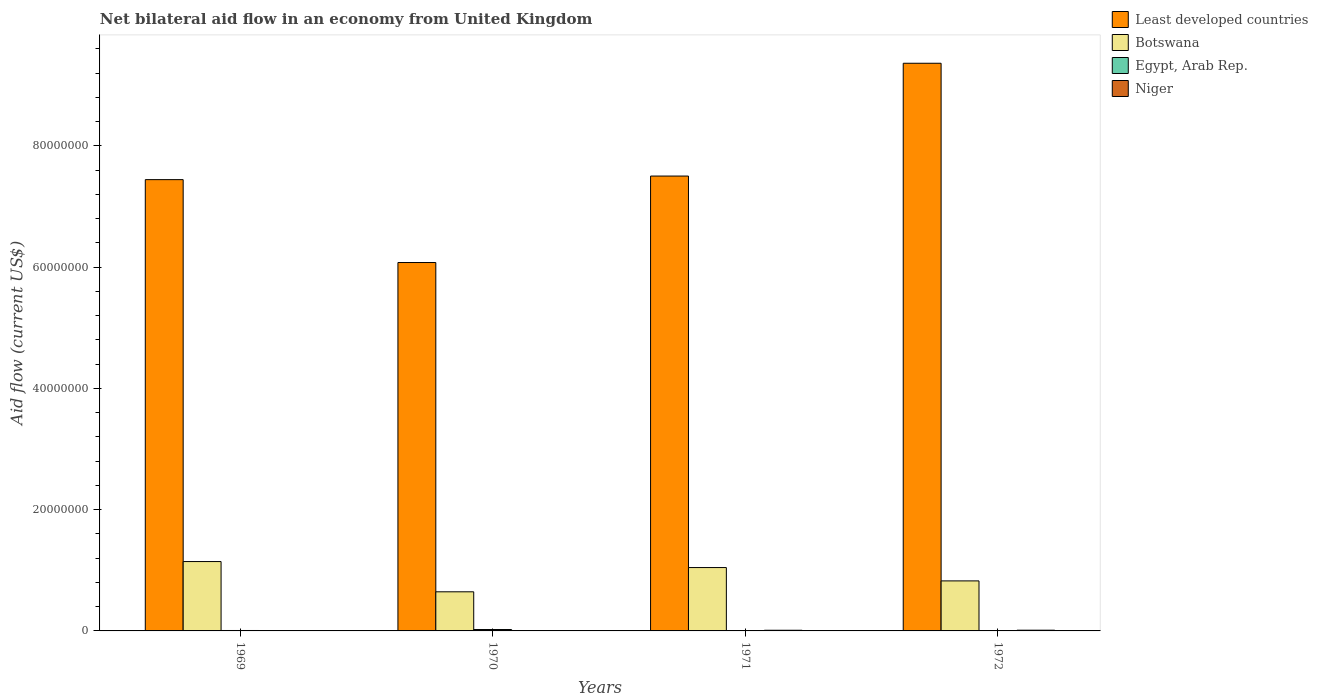How many groups of bars are there?
Provide a succinct answer. 4. Are the number of bars on each tick of the X-axis equal?
Make the answer very short. No. How many bars are there on the 2nd tick from the left?
Give a very brief answer. 4. In how many cases, is the number of bars for a given year not equal to the number of legend labels?
Give a very brief answer. 2. What is the net bilateral aid flow in Niger in 1969?
Make the answer very short. 3.00e+04. Across all years, what is the maximum net bilateral aid flow in Botswana?
Make the answer very short. 1.14e+07. Across all years, what is the minimum net bilateral aid flow in Botswana?
Make the answer very short. 6.45e+06. In which year was the net bilateral aid flow in Niger maximum?
Your answer should be very brief. 1972. What is the difference between the net bilateral aid flow in Egypt, Arab Rep. in 1972 and the net bilateral aid flow in Botswana in 1971?
Offer a very short reply. -1.04e+07. What is the average net bilateral aid flow in Botswana per year?
Your answer should be compact. 9.15e+06. In the year 1971, what is the difference between the net bilateral aid flow in Niger and net bilateral aid flow in Botswana?
Your response must be concise. -1.03e+07. In how many years, is the net bilateral aid flow in Egypt, Arab Rep. greater than 52000000 US$?
Provide a succinct answer. 0. Is the net bilateral aid flow in Niger in 1970 less than that in 1971?
Keep it short and to the point. Yes. Is the difference between the net bilateral aid flow in Niger in 1970 and 1971 greater than the difference between the net bilateral aid flow in Botswana in 1970 and 1971?
Provide a short and direct response. Yes. What is the difference between the highest and the second highest net bilateral aid flow in Least developed countries?
Keep it short and to the point. 1.86e+07. What is the difference between the highest and the lowest net bilateral aid flow in Egypt, Arab Rep.?
Make the answer very short. 2.30e+05. Is it the case that in every year, the sum of the net bilateral aid flow in Egypt, Arab Rep. and net bilateral aid flow in Least developed countries is greater than the sum of net bilateral aid flow in Botswana and net bilateral aid flow in Niger?
Your answer should be very brief. Yes. How many bars are there?
Give a very brief answer. 14. Are all the bars in the graph horizontal?
Provide a succinct answer. No. How many years are there in the graph?
Ensure brevity in your answer.  4. What is the difference between two consecutive major ticks on the Y-axis?
Offer a very short reply. 2.00e+07. Are the values on the major ticks of Y-axis written in scientific E-notation?
Your answer should be compact. No. Does the graph contain grids?
Provide a succinct answer. No. Where does the legend appear in the graph?
Provide a short and direct response. Top right. How are the legend labels stacked?
Make the answer very short. Vertical. What is the title of the graph?
Your answer should be compact. Net bilateral aid flow in an economy from United Kingdom. Does "Russian Federation" appear as one of the legend labels in the graph?
Make the answer very short. No. What is the label or title of the X-axis?
Offer a terse response. Years. What is the Aid flow (current US$) in Least developed countries in 1969?
Your response must be concise. 7.44e+07. What is the Aid flow (current US$) in Botswana in 1969?
Your answer should be compact. 1.14e+07. What is the Aid flow (current US$) in Least developed countries in 1970?
Your answer should be very brief. 6.08e+07. What is the Aid flow (current US$) of Botswana in 1970?
Offer a very short reply. 6.45e+06. What is the Aid flow (current US$) of Egypt, Arab Rep. in 1970?
Ensure brevity in your answer.  2.30e+05. What is the Aid flow (current US$) in Niger in 1970?
Keep it short and to the point. 3.00e+04. What is the Aid flow (current US$) in Least developed countries in 1971?
Make the answer very short. 7.50e+07. What is the Aid flow (current US$) of Botswana in 1971?
Provide a succinct answer. 1.04e+07. What is the Aid flow (current US$) of Least developed countries in 1972?
Offer a terse response. 9.36e+07. What is the Aid flow (current US$) of Botswana in 1972?
Your answer should be very brief. 8.25e+06. What is the Aid flow (current US$) in Egypt, Arab Rep. in 1972?
Keep it short and to the point. 0. Across all years, what is the maximum Aid flow (current US$) of Least developed countries?
Your answer should be compact. 9.36e+07. Across all years, what is the maximum Aid flow (current US$) in Botswana?
Make the answer very short. 1.14e+07. Across all years, what is the maximum Aid flow (current US$) in Egypt, Arab Rep.?
Provide a short and direct response. 2.30e+05. Across all years, what is the minimum Aid flow (current US$) of Least developed countries?
Your answer should be very brief. 6.08e+07. Across all years, what is the minimum Aid flow (current US$) in Botswana?
Provide a short and direct response. 6.45e+06. Across all years, what is the minimum Aid flow (current US$) in Egypt, Arab Rep.?
Provide a short and direct response. 0. Across all years, what is the minimum Aid flow (current US$) in Niger?
Provide a succinct answer. 3.00e+04. What is the total Aid flow (current US$) in Least developed countries in the graph?
Your response must be concise. 3.04e+08. What is the total Aid flow (current US$) in Botswana in the graph?
Give a very brief answer. 3.66e+07. What is the difference between the Aid flow (current US$) in Least developed countries in 1969 and that in 1970?
Your answer should be compact. 1.37e+07. What is the difference between the Aid flow (current US$) of Botswana in 1969 and that in 1970?
Ensure brevity in your answer.  4.99e+06. What is the difference between the Aid flow (current US$) of Niger in 1969 and that in 1970?
Your answer should be very brief. 0. What is the difference between the Aid flow (current US$) of Least developed countries in 1969 and that in 1971?
Offer a terse response. -5.90e+05. What is the difference between the Aid flow (current US$) in Botswana in 1969 and that in 1971?
Ensure brevity in your answer.  9.90e+05. What is the difference between the Aid flow (current US$) in Niger in 1969 and that in 1971?
Offer a very short reply. -8.00e+04. What is the difference between the Aid flow (current US$) of Least developed countries in 1969 and that in 1972?
Offer a terse response. -1.92e+07. What is the difference between the Aid flow (current US$) of Botswana in 1969 and that in 1972?
Provide a short and direct response. 3.19e+06. What is the difference between the Aid flow (current US$) of Least developed countries in 1970 and that in 1971?
Your answer should be compact. -1.43e+07. What is the difference between the Aid flow (current US$) of Least developed countries in 1970 and that in 1972?
Your answer should be compact. -3.29e+07. What is the difference between the Aid flow (current US$) of Botswana in 1970 and that in 1972?
Offer a terse response. -1.80e+06. What is the difference between the Aid flow (current US$) in Niger in 1970 and that in 1972?
Offer a very short reply. -9.00e+04. What is the difference between the Aid flow (current US$) of Least developed countries in 1971 and that in 1972?
Your answer should be very brief. -1.86e+07. What is the difference between the Aid flow (current US$) in Botswana in 1971 and that in 1972?
Your answer should be compact. 2.20e+06. What is the difference between the Aid flow (current US$) of Niger in 1971 and that in 1972?
Your response must be concise. -10000. What is the difference between the Aid flow (current US$) in Least developed countries in 1969 and the Aid flow (current US$) in Botswana in 1970?
Offer a very short reply. 6.80e+07. What is the difference between the Aid flow (current US$) of Least developed countries in 1969 and the Aid flow (current US$) of Egypt, Arab Rep. in 1970?
Offer a very short reply. 7.42e+07. What is the difference between the Aid flow (current US$) of Least developed countries in 1969 and the Aid flow (current US$) of Niger in 1970?
Keep it short and to the point. 7.44e+07. What is the difference between the Aid flow (current US$) in Botswana in 1969 and the Aid flow (current US$) in Egypt, Arab Rep. in 1970?
Your answer should be very brief. 1.12e+07. What is the difference between the Aid flow (current US$) in Botswana in 1969 and the Aid flow (current US$) in Niger in 1970?
Offer a very short reply. 1.14e+07. What is the difference between the Aid flow (current US$) in Egypt, Arab Rep. in 1969 and the Aid flow (current US$) in Niger in 1970?
Ensure brevity in your answer.  4.00e+04. What is the difference between the Aid flow (current US$) in Least developed countries in 1969 and the Aid flow (current US$) in Botswana in 1971?
Provide a succinct answer. 6.40e+07. What is the difference between the Aid flow (current US$) in Least developed countries in 1969 and the Aid flow (current US$) in Niger in 1971?
Your answer should be compact. 7.43e+07. What is the difference between the Aid flow (current US$) in Botswana in 1969 and the Aid flow (current US$) in Niger in 1971?
Your answer should be very brief. 1.13e+07. What is the difference between the Aid flow (current US$) of Least developed countries in 1969 and the Aid flow (current US$) of Botswana in 1972?
Your answer should be compact. 6.62e+07. What is the difference between the Aid flow (current US$) in Least developed countries in 1969 and the Aid flow (current US$) in Niger in 1972?
Ensure brevity in your answer.  7.43e+07. What is the difference between the Aid flow (current US$) of Botswana in 1969 and the Aid flow (current US$) of Niger in 1972?
Offer a terse response. 1.13e+07. What is the difference between the Aid flow (current US$) of Least developed countries in 1970 and the Aid flow (current US$) of Botswana in 1971?
Offer a terse response. 5.03e+07. What is the difference between the Aid flow (current US$) of Least developed countries in 1970 and the Aid flow (current US$) of Niger in 1971?
Give a very brief answer. 6.06e+07. What is the difference between the Aid flow (current US$) of Botswana in 1970 and the Aid flow (current US$) of Niger in 1971?
Ensure brevity in your answer.  6.34e+06. What is the difference between the Aid flow (current US$) of Egypt, Arab Rep. in 1970 and the Aid flow (current US$) of Niger in 1971?
Offer a very short reply. 1.20e+05. What is the difference between the Aid flow (current US$) in Least developed countries in 1970 and the Aid flow (current US$) in Botswana in 1972?
Give a very brief answer. 5.25e+07. What is the difference between the Aid flow (current US$) of Least developed countries in 1970 and the Aid flow (current US$) of Niger in 1972?
Your answer should be very brief. 6.06e+07. What is the difference between the Aid flow (current US$) in Botswana in 1970 and the Aid flow (current US$) in Niger in 1972?
Keep it short and to the point. 6.33e+06. What is the difference between the Aid flow (current US$) in Egypt, Arab Rep. in 1970 and the Aid flow (current US$) in Niger in 1972?
Your answer should be compact. 1.10e+05. What is the difference between the Aid flow (current US$) of Least developed countries in 1971 and the Aid flow (current US$) of Botswana in 1972?
Your response must be concise. 6.68e+07. What is the difference between the Aid flow (current US$) in Least developed countries in 1971 and the Aid flow (current US$) in Niger in 1972?
Provide a succinct answer. 7.49e+07. What is the difference between the Aid flow (current US$) of Botswana in 1971 and the Aid flow (current US$) of Niger in 1972?
Make the answer very short. 1.03e+07. What is the average Aid flow (current US$) in Least developed countries per year?
Give a very brief answer. 7.59e+07. What is the average Aid flow (current US$) of Botswana per year?
Make the answer very short. 9.15e+06. What is the average Aid flow (current US$) in Egypt, Arab Rep. per year?
Give a very brief answer. 7.50e+04. What is the average Aid flow (current US$) in Niger per year?
Offer a terse response. 7.25e+04. In the year 1969, what is the difference between the Aid flow (current US$) in Least developed countries and Aid flow (current US$) in Botswana?
Offer a very short reply. 6.30e+07. In the year 1969, what is the difference between the Aid flow (current US$) of Least developed countries and Aid flow (current US$) of Egypt, Arab Rep.?
Ensure brevity in your answer.  7.44e+07. In the year 1969, what is the difference between the Aid flow (current US$) of Least developed countries and Aid flow (current US$) of Niger?
Provide a succinct answer. 7.44e+07. In the year 1969, what is the difference between the Aid flow (current US$) in Botswana and Aid flow (current US$) in Egypt, Arab Rep.?
Provide a succinct answer. 1.14e+07. In the year 1969, what is the difference between the Aid flow (current US$) of Botswana and Aid flow (current US$) of Niger?
Keep it short and to the point. 1.14e+07. In the year 1970, what is the difference between the Aid flow (current US$) in Least developed countries and Aid flow (current US$) in Botswana?
Your answer should be compact. 5.43e+07. In the year 1970, what is the difference between the Aid flow (current US$) in Least developed countries and Aid flow (current US$) in Egypt, Arab Rep.?
Your answer should be compact. 6.05e+07. In the year 1970, what is the difference between the Aid flow (current US$) of Least developed countries and Aid flow (current US$) of Niger?
Your response must be concise. 6.07e+07. In the year 1970, what is the difference between the Aid flow (current US$) of Botswana and Aid flow (current US$) of Egypt, Arab Rep.?
Keep it short and to the point. 6.22e+06. In the year 1970, what is the difference between the Aid flow (current US$) in Botswana and Aid flow (current US$) in Niger?
Ensure brevity in your answer.  6.42e+06. In the year 1971, what is the difference between the Aid flow (current US$) of Least developed countries and Aid flow (current US$) of Botswana?
Make the answer very short. 6.46e+07. In the year 1971, what is the difference between the Aid flow (current US$) in Least developed countries and Aid flow (current US$) in Niger?
Provide a short and direct response. 7.49e+07. In the year 1971, what is the difference between the Aid flow (current US$) in Botswana and Aid flow (current US$) in Niger?
Your answer should be very brief. 1.03e+07. In the year 1972, what is the difference between the Aid flow (current US$) of Least developed countries and Aid flow (current US$) of Botswana?
Ensure brevity in your answer.  8.54e+07. In the year 1972, what is the difference between the Aid flow (current US$) of Least developed countries and Aid flow (current US$) of Niger?
Your answer should be compact. 9.35e+07. In the year 1972, what is the difference between the Aid flow (current US$) of Botswana and Aid flow (current US$) of Niger?
Your response must be concise. 8.13e+06. What is the ratio of the Aid flow (current US$) in Least developed countries in 1969 to that in 1970?
Give a very brief answer. 1.23. What is the ratio of the Aid flow (current US$) of Botswana in 1969 to that in 1970?
Offer a terse response. 1.77. What is the ratio of the Aid flow (current US$) in Egypt, Arab Rep. in 1969 to that in 1970?
Provide a succinct answer. 0.3. What is the ratio of the Aid flow (current US$) in Niger in 1969 to that in 1970?
Your answer should be compact. 1. What is the ratio of the Aid flow (current US$) in Botswana in 1969 to that in 1971?
Give a very brief answer. 1.09. What is the ratio of the Aid flow (current US$) of Niger in 1969 to that in 1971?
Your response must be concise. 0.27. What is the ratio of the Aid flow (current US$) of Least developed countries in 1969 to that in 1972?
Your response must be concise. 0.8. What is the ratio of the Aid flow (current US$) in Botswana in 1969 to that in 1972?
Your response must be concise. 1.39. What is the ratio of the Aid flow (current US$) in Niger in 1969 to that in 1972?
Ensure brevity in your answer.  0.25. What is the ratio of the Aid flow (current US$) of Least developed countries in 1970 to that in 1971?
Make the answer very short. 0.81. What is the ratio of the Aid flow (current US$) of Botswana in 1970 to that in 1971?
Make the answer very short. 0.62. What is the ratio of the Aid flow (current US$) in Niger in 1970 to that in 1971?
Make the answer very short. 0.27. What is the ratio of the Aid flow (current US$) of Least developed countries in 1970 to that in 1972?
Provide a succinct answer. 0.65. What is the ratio of the Aid flow (current US$) of Botswana in 1970 to that in 1972?
Your response must be concise. 0.78. What is the ratio of the Aid flow (current US$) in Least developed countries in 1971 to that in 1972?
Your answer should be very brief. 0.8. What is the ratio of the Aid flow (current US$) of Botswana in 1971 to that in 1972?
Make the answer very short. 1.27. What is the difference between the highest and the second highest Aid flow (current US$) in Least developed countries?
Keep it short and to the point. 1.86e+07. What is the difference between the highest and the second highest Aid flow (current US$) in Botswana?
Ensure brevity in your answer.  9.90e+05. What is the difference between the highest and the lowest Aid flow (current US$) in Least developed countries?
Ensure brevity in your answer.  3.29e+07. What is the difference between the highest and the lowest Aid flow (current US$) of Botswana?
Ensure brevity in your answer.  4.99e+06. What is the difference between the highest and the lowest Aid flow (current US$) in Egypt, Arab Rep.?
Give a very brief answer. 2.30e+05. What is the difference between the highest and the lowest Aid flow (current US$) of Niger?
Your response must be concise. 9.00e+04. 